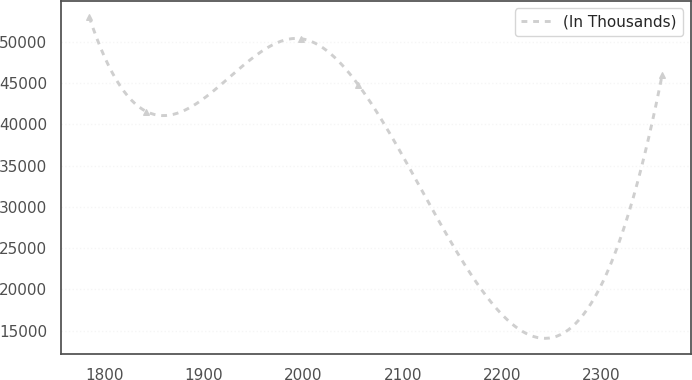<chart> <loc_0><loc_0><loc_500><loc_500><line_chart><ecel><fcel>(In Thousands)<nl><fcel>1784.82<fcel>52999.6<nl><fcel>1842.41<fcel>41536.3<nl><fcel>1997.85<fcel>50361.4<nl><fcel>2055.44<fcel>44765.1<nl><fcel>2360.73<fcel>45911.4<nl></chart> 